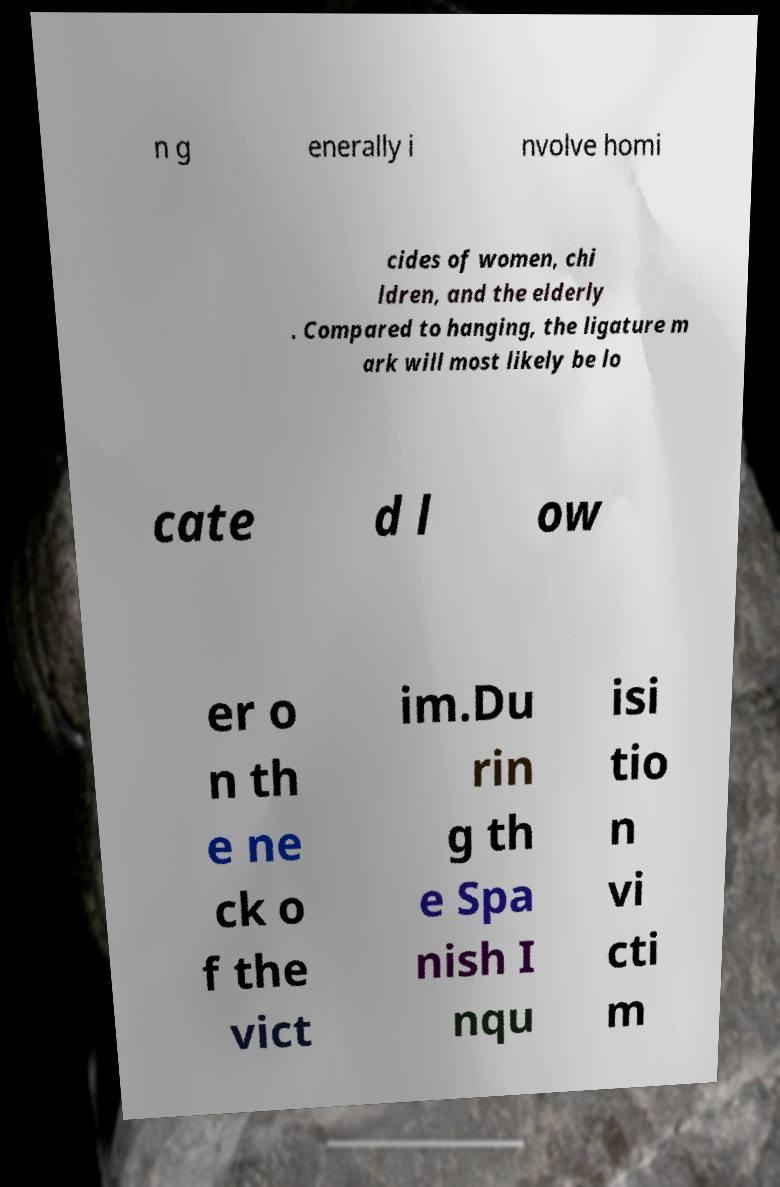I need the written content from this picture converted into text. Can you do that? n g enerally i nvolve homi cides of women, chi ldren, and the elderly . Compared to hanging, the ligature m ark will most likely be lo cate d l ow er o n th e ne ck o f the vict im.Du rin g th e Spa nish I nqu isi tio n vi cti m 